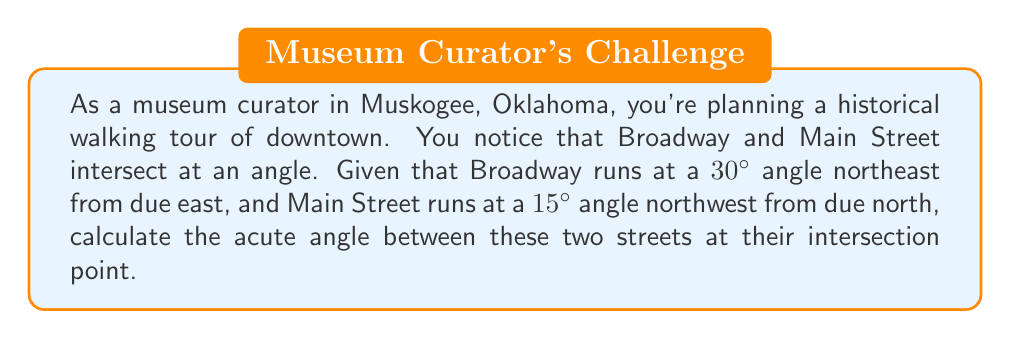Can you solve this math problem? To solve this problem, we can use the concepts of direction angles and vector algebra. Let's approach this step-by-step:

1) First, let's define our coordinate system:
   - East is the positive x-axis (0°)
   - North is the positive y-axis (90°)

2) Now, let's determine the direction angles of each street:
   - Broadway: 30° northeast from due east = 30°
   - Main Street: 15° northwest from due north = 90° + 15° = 105°

3) We can represent each street as a vector using these angles:
   - Broadway vector: $\vec{v_1} = (\cos 30°, \sin 30°)$
   - Main Street vector: $\vec{v_2} = (\cos 105°, \sin 105°)$

4) The angle between two vectors can be found using the dot product formula:

   $$\cos \theta = \frac{\vec{v_1} \cdot \vec{v_2}}{|\vec{v_1}||\vec{v_2}|}$$

5) Let's calculate the dot product:
   $$\vec{v_1} \cdot \vec{v_2} = (\cos 30°)(\cos 105°) + (\sin 30°)(\sin 105°)$$

6) The magnitude of each vector is 1, so $|\vec{v_1}| = |\vec{v_2}| = 1$

7) Substituting into the formula:
   $$\cos \theta = (\cos 30°)(\cos 105°) + (\sin 30°)(\sin 105°)$$

8) Using a calculator or trigonometric identities:
   $$\cos \theta \approx -0.2588$$

9) Taking the inverse cosine (arccos) of both sides:
   $$\theta = \arccos(-0.2588) \approx 105°$$

10) This gives us the obtuse angle. For the acute angle, we subtract from 180°:
    $$180° - 105° = 75°$$

Therefore, the acute angle between Broadway and Main Street is approximately 75°.
Answer: The acute angle between Broadway and Main Street in downtown Muskogee is approximately 75°. 